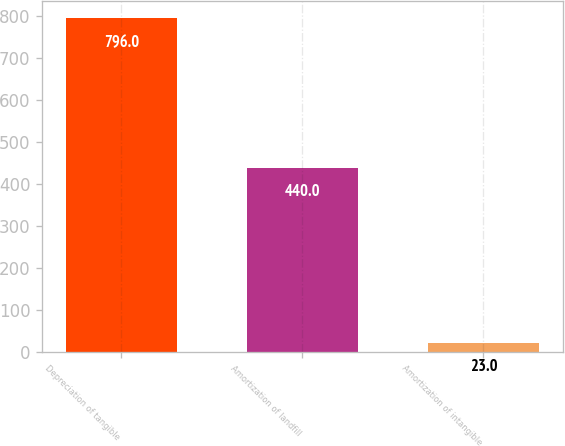Convert chart. <chart><loc_0><loc_0><loc_500><loc_500><bar_chart><fcel>Depreciation of tangible<fcel>Amortization of landfill<fcel>Amortization of intangible<nl><fcel>796<fcel>440<fcel>23<nl></chart> 